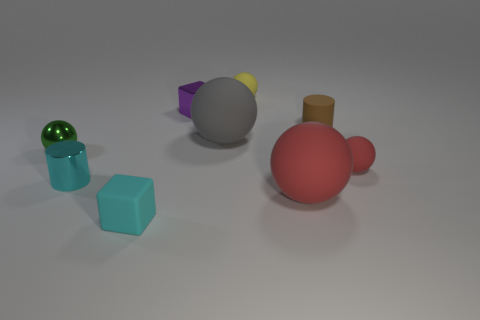Is the number of brown rubber cylinders in front of the metal sphere less than the number of cyan cylinders?
Give a very brief answer. Yes. Is there any other thing that is the same shape as the tiny cyan shiny thing?
Keep it short and to the point. Yes. There is a tiny metal object in front of the tiny red ball; what is its shape?
Your answer should be very brief. Cylinder. The large matte object that is right of the tiny matte sphere behind the ball that is to the left of the purple object is what shape?
Your answer should be very brief. Sphere. How many objects are either small metal blocks or small green spheres?
Your response must be concise. 2. There is a large object to the right of the gray thing; is it the same shape as the tiny shiny object in front of the green thing?
Your answer should be very brief. No. How many spheres are right of the small cyan shiny cylinder and behind the tiny cyan cylinder?
Offer a very short reply. 3. What number of other things are there of the same size as the purple object?
Your response must be concise. 6. There is a tiny ball that is on the left side of the tiny rubber cylinder and in front of the purple thing; what material is it?
Keep it short and to the point. Metal. There is a small metal sphere; is it the same color as the cylinder right of the large gray sphere?
Provide a succinct answer. No. 